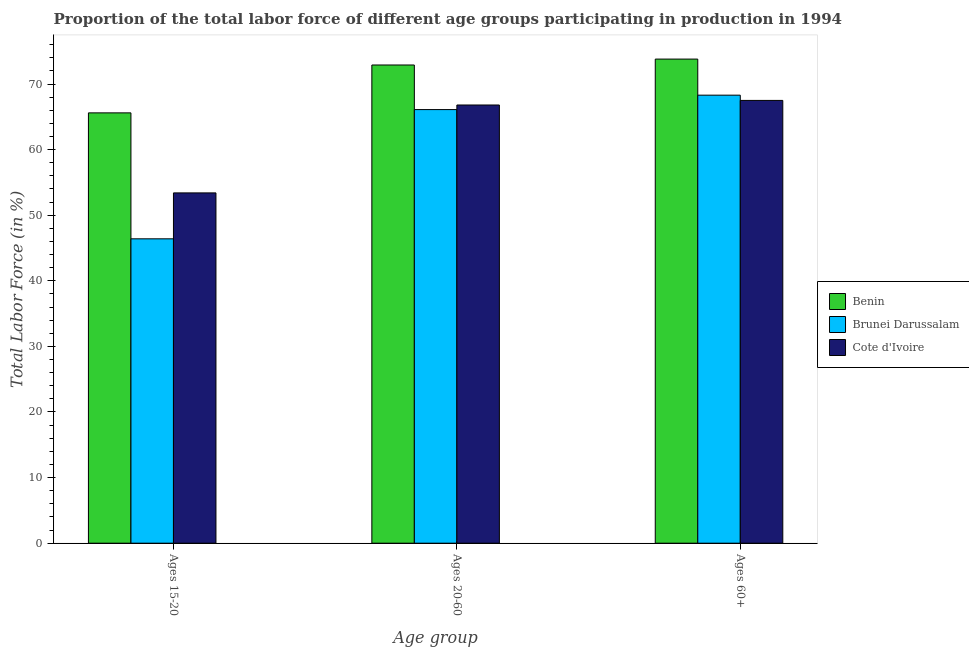How many different coloured bars are there?
Ensure brevity in your answer.  3. How many groups of bars are there?
Make the answer very short. 3. Are the number of bars per tick equal to the number of legend labels?
Give a very brief answer. Yes. How many bars are there on the 2nd tick from the left?
Provide a short and direct response. 3. What is the label of the 2nd group of bars from the left?
Make the answer very short. Ages 20-60. What is the percentage of labor force within the age group 15-20 in Brunei Darussalam?
Keep it short and to the point. 46.4. Across all countries, what is the maximum percentage of labor force within the age group 15-20?
Provide a short and direct response. 65.6. Across all countries, what is the minimum percentage of labor force within the age group 20-60?
Provide a succinct answer. 66.1. In which country was the percentage of labor force within the age group 20-60 maximum?
Your response must be concise. Benin. In which country was the percentage of labor force above age 60 minimum?
Offer a terse response. Cote d'Ivoire. What is the total percentage of labor force above age 60 in the graph?
Your response must be concise. 209.6. What is the difference between the percentage of labor force within the age group 20-60 in Benin and that in Cote d'Ivoire?
Provide a succinct answer. 6.1. What is the difference between the percentage of labor force within the age group 15-20 in Brunei Darussalam and the percentage of labor force above age 60 in Cote d'Ivoire?
Your answer should be very brief. -21.1. What is the average percentage of labor force within the age group 15-20 per country?
Offer a terse response. 55.13. What is the difference between the percentage of labor force within the age group 15-20 and percentage of labor force within the age group 20-60 in Cote d'Ivoire?
Your response must be concise. -13.4. In how many countries, is the percentage of labor force within the age group 20-60 greater than 28 %?
Keep it short and to the point. 3. What is the ratio of the percentage of labor force within the age group 20-60 in Cote d'Ivoire to that in Benin?
Give a very brief answer. 0.92. Is the difference between the percentage of labor force within the age group 20-60 in Cote d'Ivoire and Brunei Darussalam greater than the difference between the percentage of labor force above age 60 in Cote d'Ivoire and Brunei Darussalam?
Keep it short and to the point. Yes. What is the difference between the highest and the second highest percentage of labor force within the age group 15-20?
Keep it short and to the point. 12.2. What is the difference between the highest and the lowest percentage of labor force within the age group 15-20?
Give a very brief answer. 19.2. What does the 3rd bar from the left in Ages 15-20 represents?
Keep it short and to the point. Cote d'Ivoire. What does the 3rd bar from the right in Ages 15-20 represents?
Provide a succinct answer. Benin. Is it the case that in every country, the sum of the percentage of labor force within the age group 15-20 and percentage of labor force within the age group 20-60 is greater than the percentage of labor force above age 60?
Offer a terse response. Yes. How many bars are there?
Make the answer very short. 9. Are all the bars in the graph horizontal?
Ensure brevity in your answer.  No. How many countries are there in the graph?
Offer a terse response. 3. What is the difference between two consecutive major ticks on the Y-axis?
Make the answer very short. 10. Are the values on the major ticks of Y-axis written in scientific E-notation?
Keep it short and to the point. No. Does the graph contain any zero values?
Offer a very short reply. No. Does the graph contain grids?
Give a very brief answer. No. How are the legend labels stacked?
Keep it short and to the point. Vertical. What is the title of the graph?
Provide a succinct answer. Proportion of the total labor force of different age groups participating in production in 1994. Does "Cyprus" appear as one of the legend labels in the graph?
Your response must be concise. No. What is the label or title of the X-axis?
Keep it short and to the point. Age group. What is the Total Labor Force (in %) in Benin in Ages 15-20?
Offer a terse response. 65.6. What is the Total Labor Force (in %) of Brunei Darussalam in Ages 15-20?
Make the answer very short. 46.4. What is the Total Labor Force (in %) of Cote d'Ivoire in Ages 15-20?
Offer a very short reply. 53.4. What is the Total Labor Force (in %) in Benin in Ages 20-60?
Keep it short and to the point. 72.9. What is the Total Labor Force (in %) in Brunei Darussalam in Ages 20-60?
Your response must be concise. 66.1. What is the Total Labor Force (in %) of Cote d'Ivoire in Ages 20-60?
Give a very brief answer. 66.8. What is the Total Labor Force (in %) in Benin in Ages 60+?
Ensure brevity in your answer.  73.8. What is the Total Labor Force (in %) in Brunei Darussalam in Ages 60+?
Provide a succinct answer. 68.3. What is the Total Labor Force (in %) of Cote d'Ivoire in Ages 60+?
Provide a short and direct response. 67.5. Across all Age group, what is the maximum Total Labor Force (in %) in Benin?
Offer a terse response. 73.8. Across all Age group, what is the maximum Total Labor Force (in %) of Brunei Darussalam?
Your answer should be compact. 68.3. Across all Age group, what is the maximum Total Labor Force (in %) of Cote d'Ivoire?
Provide a short and direct response. 67.5. Across all Age group, what is the minimum Total Labor Force (in %) in Benin?
Offer a terse response. 65.6. Across all Age group, what is the minimum Total Labor Force (in %) in Brunei Darussalam?
Your response must be concise. 46.4. Across all Age group, what is the minimum Total Labor Force (in %) in Cote d'Ivoire?
Give a very brief answer. 53.4. What is the total Total Labor Force (in %) in Benin in the graph?
Your answer should be compact. 212.3. What is the total Total Labor Force (in %) in Brunei Darussalam in the graph?
Provide a short and direct response. 180.8. What is the total Total Labor Force (in %) in Cote d'Ivoire in the graph?
Your answer should be very brief. 187.7. What is the difference between the Total Labor Force (in %) of Benin in Ages 15-20 and that in Ages 20-60?
Your answer should be compact. -7.3. What is the difference between the Total Labor Force (in %) in Brunei Darussalam in Ages 15-20 and that in Ages 20-60?
Provide a short and direct response. -19.7. What is the difference between the Total Labor Force (in %) of Brunei Darussalam in Ages 15-20 and that in Ages 60+?
Provide a short and direct response. -21.9. What is the difference between the Total Labor Force (in %) of Cote d'Ivoire in Ages 15-20 and that in Ages 60+?
Make the answer very short. -14.1. What is the difference between the Total Labor Force (in %) of Brunei Darussalam in Ages 20-60 and that in Ages 60+?
Make the answer very short. -2.2. What is the difference between the Total Labor Force (in %) in Brunei Darussalam in Ages 15-20 and the Total Labor Force (in %) in Cote d'Ivoire in Ages 20-60?
Provide a short and direct response. -20.4. What is the difference between the Total Labor Force (in %) in Benin in Ages 15-20 and the Total Labor Force (in %) in Brunei Darussalam in Ages 60+?
Provide a succinct answer. -2.7. What is the difference between the Total Labor Force (in %) in Brunei Darussalam in Ages 15-20 and the Total Labor Force (in %) in Cote d'Ivoire in Ages 60+?
Offer a very short reply. -21.1. What is the difference between the Total Labor Force (in %) in Brunei Darussalam in Ages 20-60 and the Total Labor Force (in %) in Cote d'Ivoire in Ages 60+?
Your answer should be very brief. -1.4. What is the average Total Labor Force (in %) in Benin per Age group?
Give a very brief answer. 70.77. What is the average Total Labor Force (in %) of Brunei Darussalam per Age group?
Provide a succinct answer. 60.27. What is the average Total Labor Force (in %) in Cote d'Ivoire per Age group?
Your answer should be very brief. 62.57. What is the difference between the Total Labor Force (in %) of Benin and Total Labor Force (in %) of Cote d'Ivoire in Ages 15-20?
Ensure brevity in your answer.  12.2. What is the difference between the Total Labor Force (in %) in Brunei Darussalam and Total Labor Force (in %) in Cote d'Ivoire in Ages 15-20?
Your response must be concise. -7. What is the difference between the Total Labor Force (in %) in Benin and Total Labor Force (in %) in Brunei Darussalam in Ages 20-60?
Provide a succinct answer. 6.8. What is the difference between the Total Labor Force (in %) in Benin and Total Labor Force (in %) in Cote d'Ivoire in Ages 20-60?
Your response must be concise. 6.1. What is the difference between the Total Labor Force (in %) in Benin and Total Labor Force (in %) in Brunei Darussalam in Ages 60+?
Offer a very short reply. 5.5. What is the ratio of the Total Labor Force (in %) of Benin in Ages 15-20 to that in Ages 20-60?
Provide a succinct answer. 0.9. What is the ratio of the Total Labor Force (in %) in Brunei Darussalam in Ages 15-20 to that in Ages 20-60?
Your response must be concise. 0.7. What is the ratio of the Total Labor Force (in %) in Cote d'Ivoire in Ages 15-20 to that in Ages 20-60?
Offer a terse response. 0.8. What is the ratio of the Total Labor Force (in %) in Benin in Ages 15-20 to that in Ages 60+?
Offer a terse response. 0.89. What is the ratio of the Total Labor Force (in %) in Brunei Darussalam in Ages 15-20 to that in Ages 60+?
Keep it short and to the point. 0.68. What is the ratio of the Total Labor Force (in %) in Cote d'Ivoire in Ages 15-20 to that in Ages 60+?
Offer a terse response. 0.79. What is the ratio of the Total Labor Force (in %) in Benin in Ages 20-60 to that in Ages 60+?
Your answer should be compact. 0.99. What is the ratio of the Total Labor Force (in %) of Brunei Darussalam in Ages 20-60 to that in Ages 60+?
Provide a short and direct response. 0.97. What is the ratio of the Total Labor Force (in %) of Cote d'Ivoire in Ages 20-60 to that in Ages 60+?
Your answer should be compact. 0.99. What is the difference between the highest and the lowest Total Labor Force (in %) in Benin?
Make the answer very short. 8.2. What is the difference between the highest and the lowest Total Labor Force (in %) of Brunei Darussalam?
Your answer should be compact. 21.9. What is the difference between the highest and the lowest Total Labor Force (in %) in Cote d'Ivoire?
Provide a succinct answer. 14.1. 